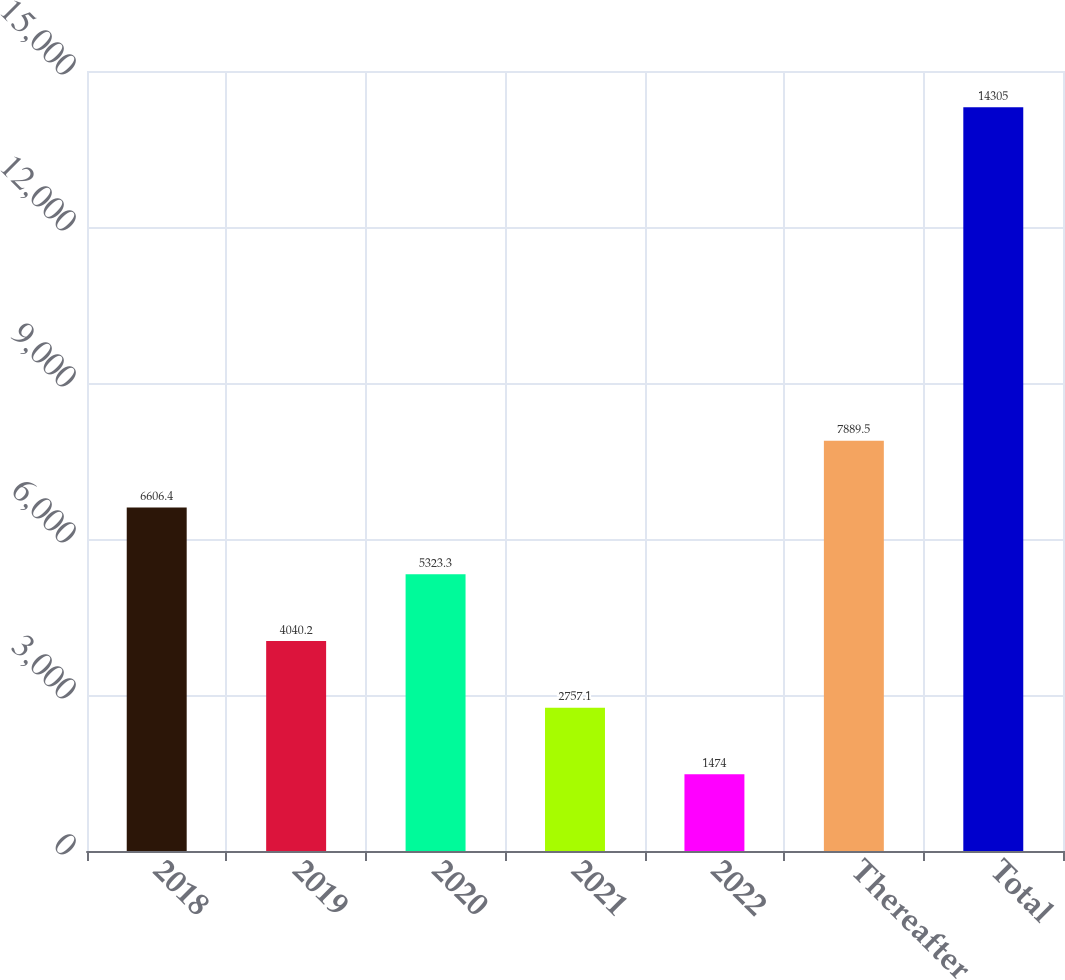<chart> <loc_0><loc_0><loc_500><loc_500><bar_chart><fcel>2018<fcel>2019<fcel>2020<fcel>2021<fcel>2022<fcel>Thereafter<fcel>Total<nl><fcel>6606.4<fcel>4040.2<fcel>5323.3<fcel>2757.1<fcel>1474<fcel>7889.5<fcel>14305<nl></chart> 